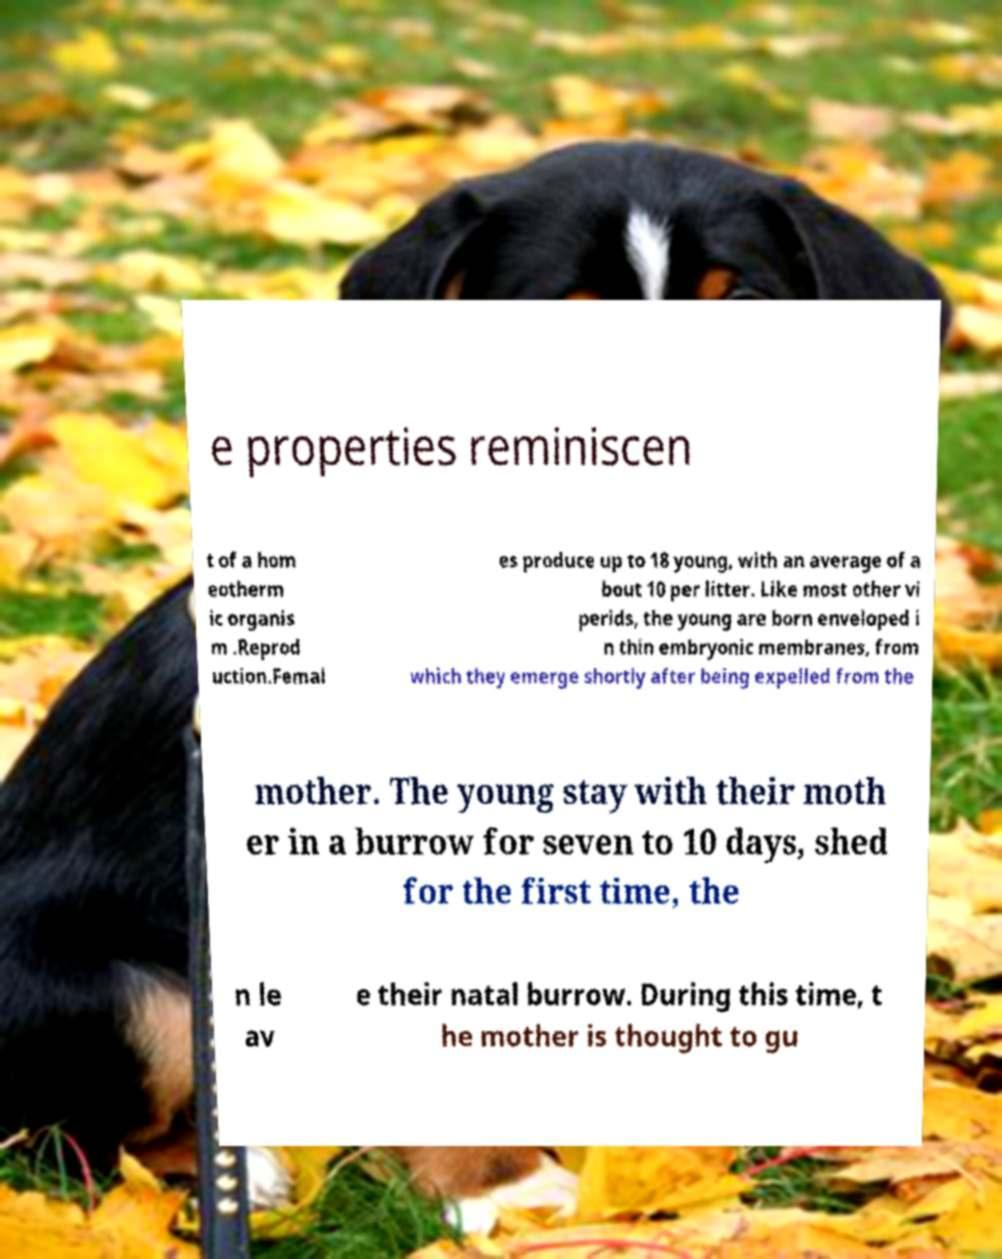Could you assist in decoding the text presented in this image and type it out clearly? e properties reminiscen t of a hom eotherm ic organis m .Reprod uction.Femal es produce up to 18 young, with an average of a bout 10 per litter. Like most other vi perids, the young are born enveloped i n thin embryonic membranes, from which they emerge shortly after being expelled from the mother. The young stay with their moth er in a burrow for seven to 10 days, shed for the first time, the n le av e their natal burrow. During this time, t he mother is thought to gu 